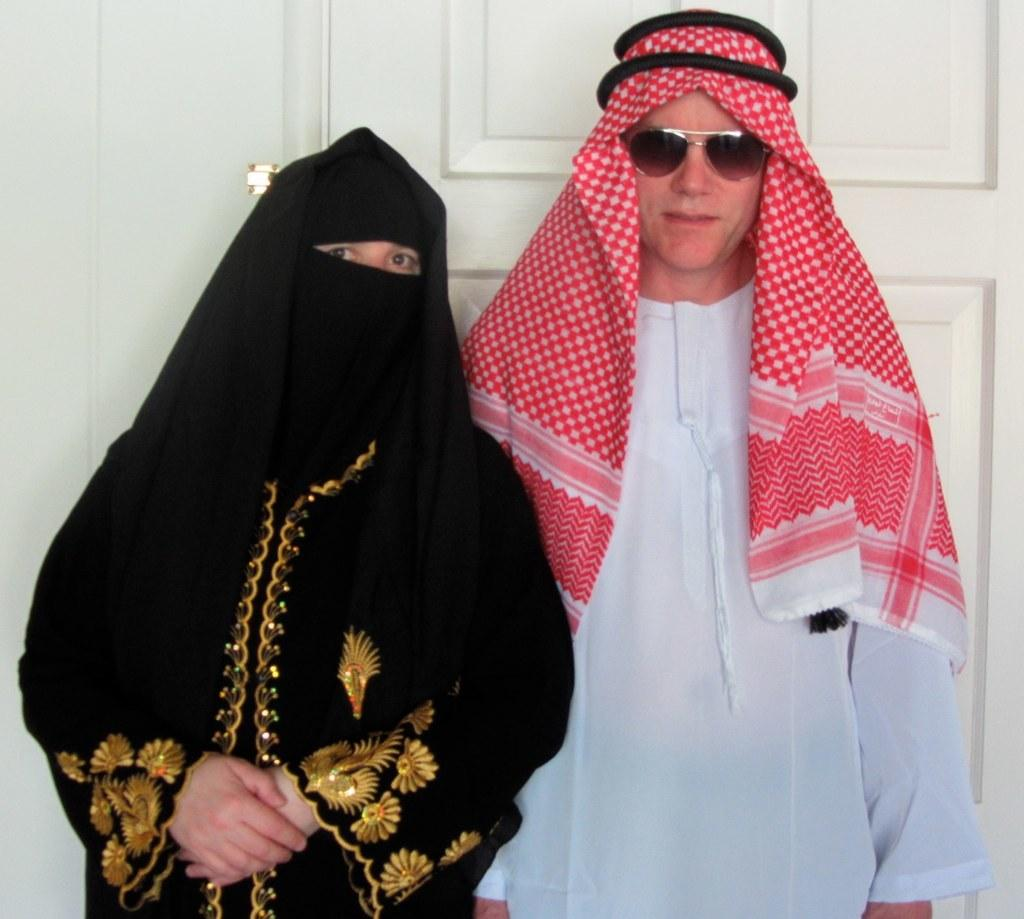How many people are in the image? There are two persons in the image. What is one of the persons wearing? One of the persons is wearing goggles. What can be seen in the background of the image? There is a wall and a door in the background of the image. What is the profit margin of the carpenter in the image? There is no carpenter or mention of profit in the image. 